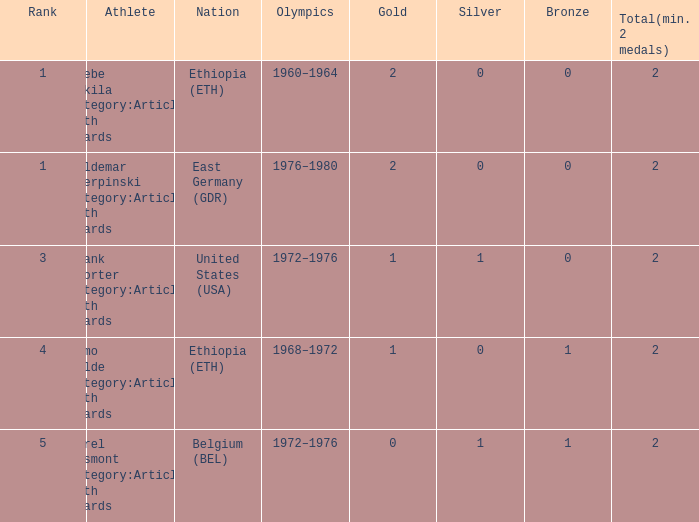What is the smallest sum of total medals earned? 2.0. 